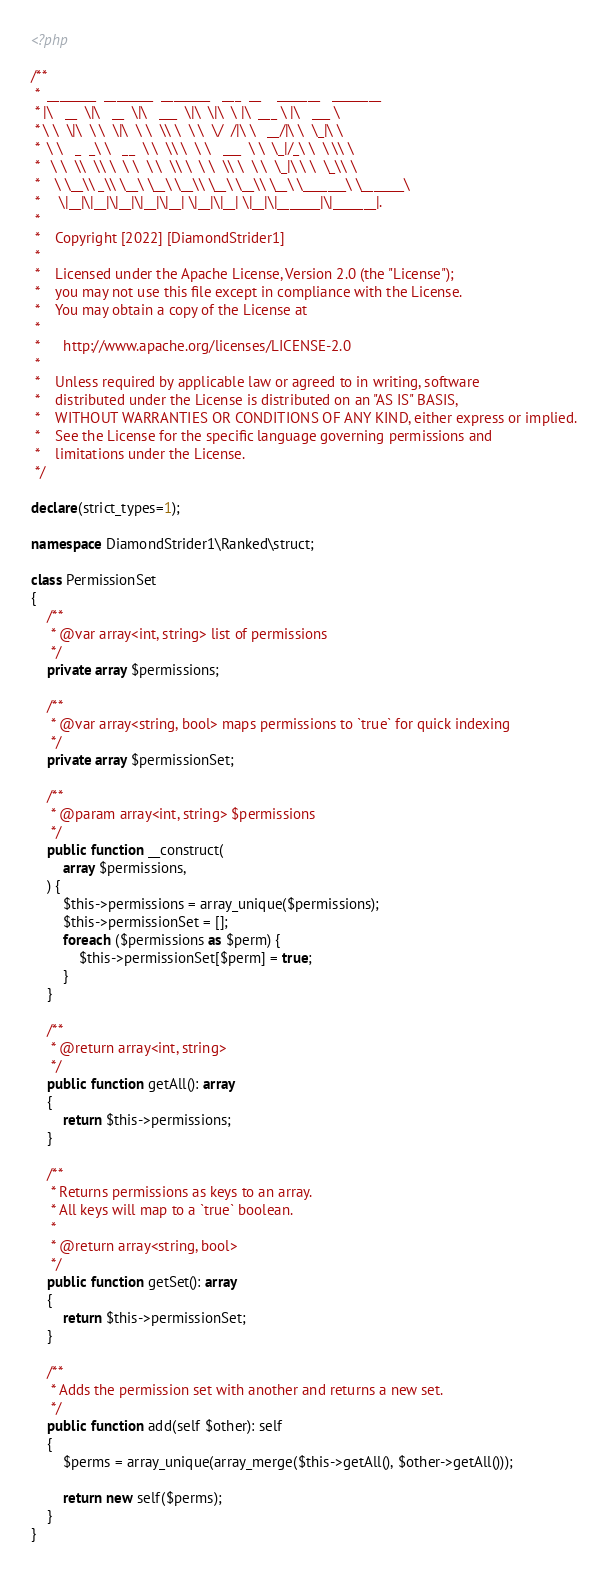Convert code to text. <code><loc_0><loc_0><loc_500><loc_500><_PHP_><?php

/**
 *  ________  ________  ________   ___  __    _______   ________
 * |\   __  \|\   __  \|\   ___  \|\  \|\  \ |\  ___ \ |\   ___ \
 * \ \  \|\  \ \  \|\  \ \  \\ \  \ \  \/  /|\ \   __/|\ \  \_|\ \
 *  \ \   _  _\ \   __  \ \  \\ \  \ \   ___  \ \  \_|/_\ \  \ \\ \
 *   \ \  \\  \\ \  \ \  \ \  \\ \  \ \  \\ \  \ \  \_|\ \ \  \_\\ \
 *    \ \__\\ _\\ \__\ \__\ \__\\ \__\ \__\\ \__\ \_______\ \_______\
 *     \|__|\|__|\|__|\|__|\|__| \|__|\|__| \|__|\|_______|\|_______|.
 *
 *    Copyright [2022] [DiamondStrider1]
 *
 *    Licensed under the Apache License, Version 2.0 (the "License");
 *    you may not use this file except in compliance with the License.
 *    You may obtain a copy of the License at
 *
 *      http://www.apache.org/licenses/LICENSE-2.0
 *
 *    Unless required by applicable law or agreed to in writing, software
 *    distributed under the License is distributed on an "AS IS" BASIS,
 *    WITHOUT WARRANTIES OR CONDITIONS OF ANY KIND, either express or implied.
 *    See the License for the specific language governing permissions and
 *    limitations under the License.
 */

declare(strict_types=1);

namespace DiamondStrider1\Ranked\struct;

class PermissionSet
{
    /**
     * @var array<int, string> list of permissions
     */
    private array $permissions;

    /**
     * @var array<string, bool> maps permissions to `true` for quick indexing
     */
    private array $permissionSet;

    /**
     * @param array<int, string> $permissions
     */
    public function __construct(
        array $permissions,
    ) {
        $this->permissions = array_unique($permissions);
        $this->permissionSet = [];
        foreach ($permissions as $perm) {
            $this->permissionSet[$perm] = true;
        }
    }

    /**
     * @return array<int, string>
     */
    public function getAll(): array
    {
        return $this->permissions;
    }

    /**
     * Returns permissions as keys to an array.
     * All keys will map to a `true` boolean.
     *
     * @return array<string, bool>
     */
    public function getSet(): array
    {
        return $this->permissionSet;
    }

    /**
     * Adds the permission set with another and returns a new set.
     */
    public function add(self $other): self
    {
        $perms = array_unique(array_merge($this->getAll(), $other->getAll()));

        return new self($perms);
    }
}
</code> 